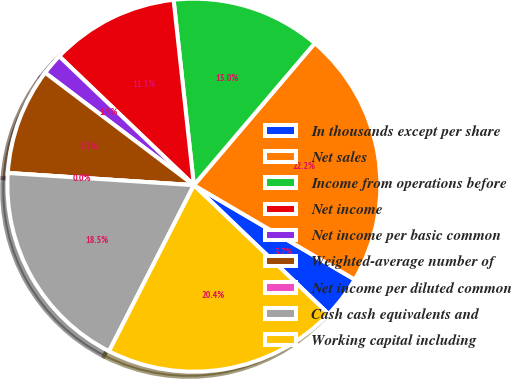<chart> <loc_0><loc_0><loc_500><loc_500><pie_chart><fcel>In thousands except per share<fcel>Net sales<fcel>Income from operations before<fcel>Net income<fcel>Net income per basic common<fcel>Weighted-average number of<fcel>Net income per diluted common<fcel>Cash cash equivalents and<fcel>Working capital including<nl><fcel>3.7%<fcel>22.22%<fcel>12.96%<fcel>11.11%<fcel>1.85%<fcel>9.26%<fcel>0.0%<fcel>18.52%<fcel>20.37%<nl></chart> 